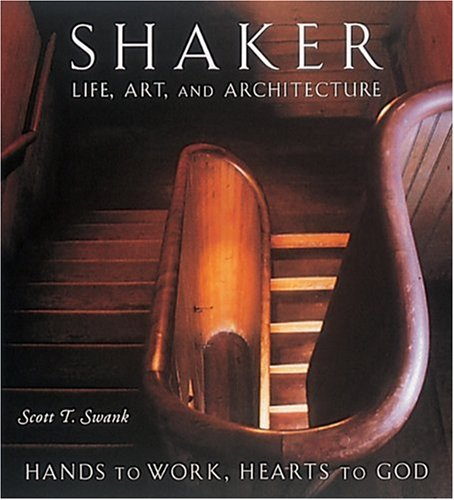Is this christianity book? Yes, this book deals with aspects of Christianity as it explores the Shaker sect, a religious group that branched from the Quakers and is known for its simple living, architecture, and furniture. 